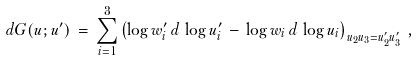<formula> <loc_0><loc_0><loc_500><loc_500>d G ( u ; u ^ { \prime } ) \, = \, \sum _ { i = 1 } ^ { 3 } \left ( \log w _ { i } ^ { \prime } \, d \, \log u _ { i } ^ { \prime } \, - \, \log w _ { i } \, d \, \log u _ { i } \right ) _ { u _ { 2 } u _ { 3 } = u _ { 2 } ^ { \prime } u _ { 3 } ^ { \prime } } \, ,</formula> 